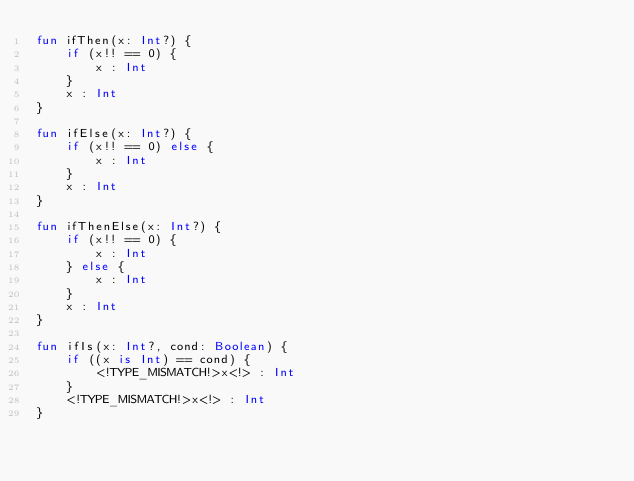Convert code to text. <code><loc_0><loc_0><loc_500><loc_500><_Kotlin_>fun ifThen(x: Int?) {
    if (x!! == 0) {
        x : Int
    }
    x : Int
}

fun ifElse(x: Int?) {
    if (x!! == 0) else {
        x : Int
    }
    x : Int
}

fun ifThenElse(x: Int?) {
    if (x!! == 0) {
        x : Int
    } else {
        x : Int
    }
    x : Int
}

fun ifIs(x: Int?, cond: Boolean) {
    if ((x is Int) == cond) {
        <!TYPE_MISMATCH!>x<!> : Int
    }
    <!TYPE_MISMATCH!>x<!> : Int
}
</code> 